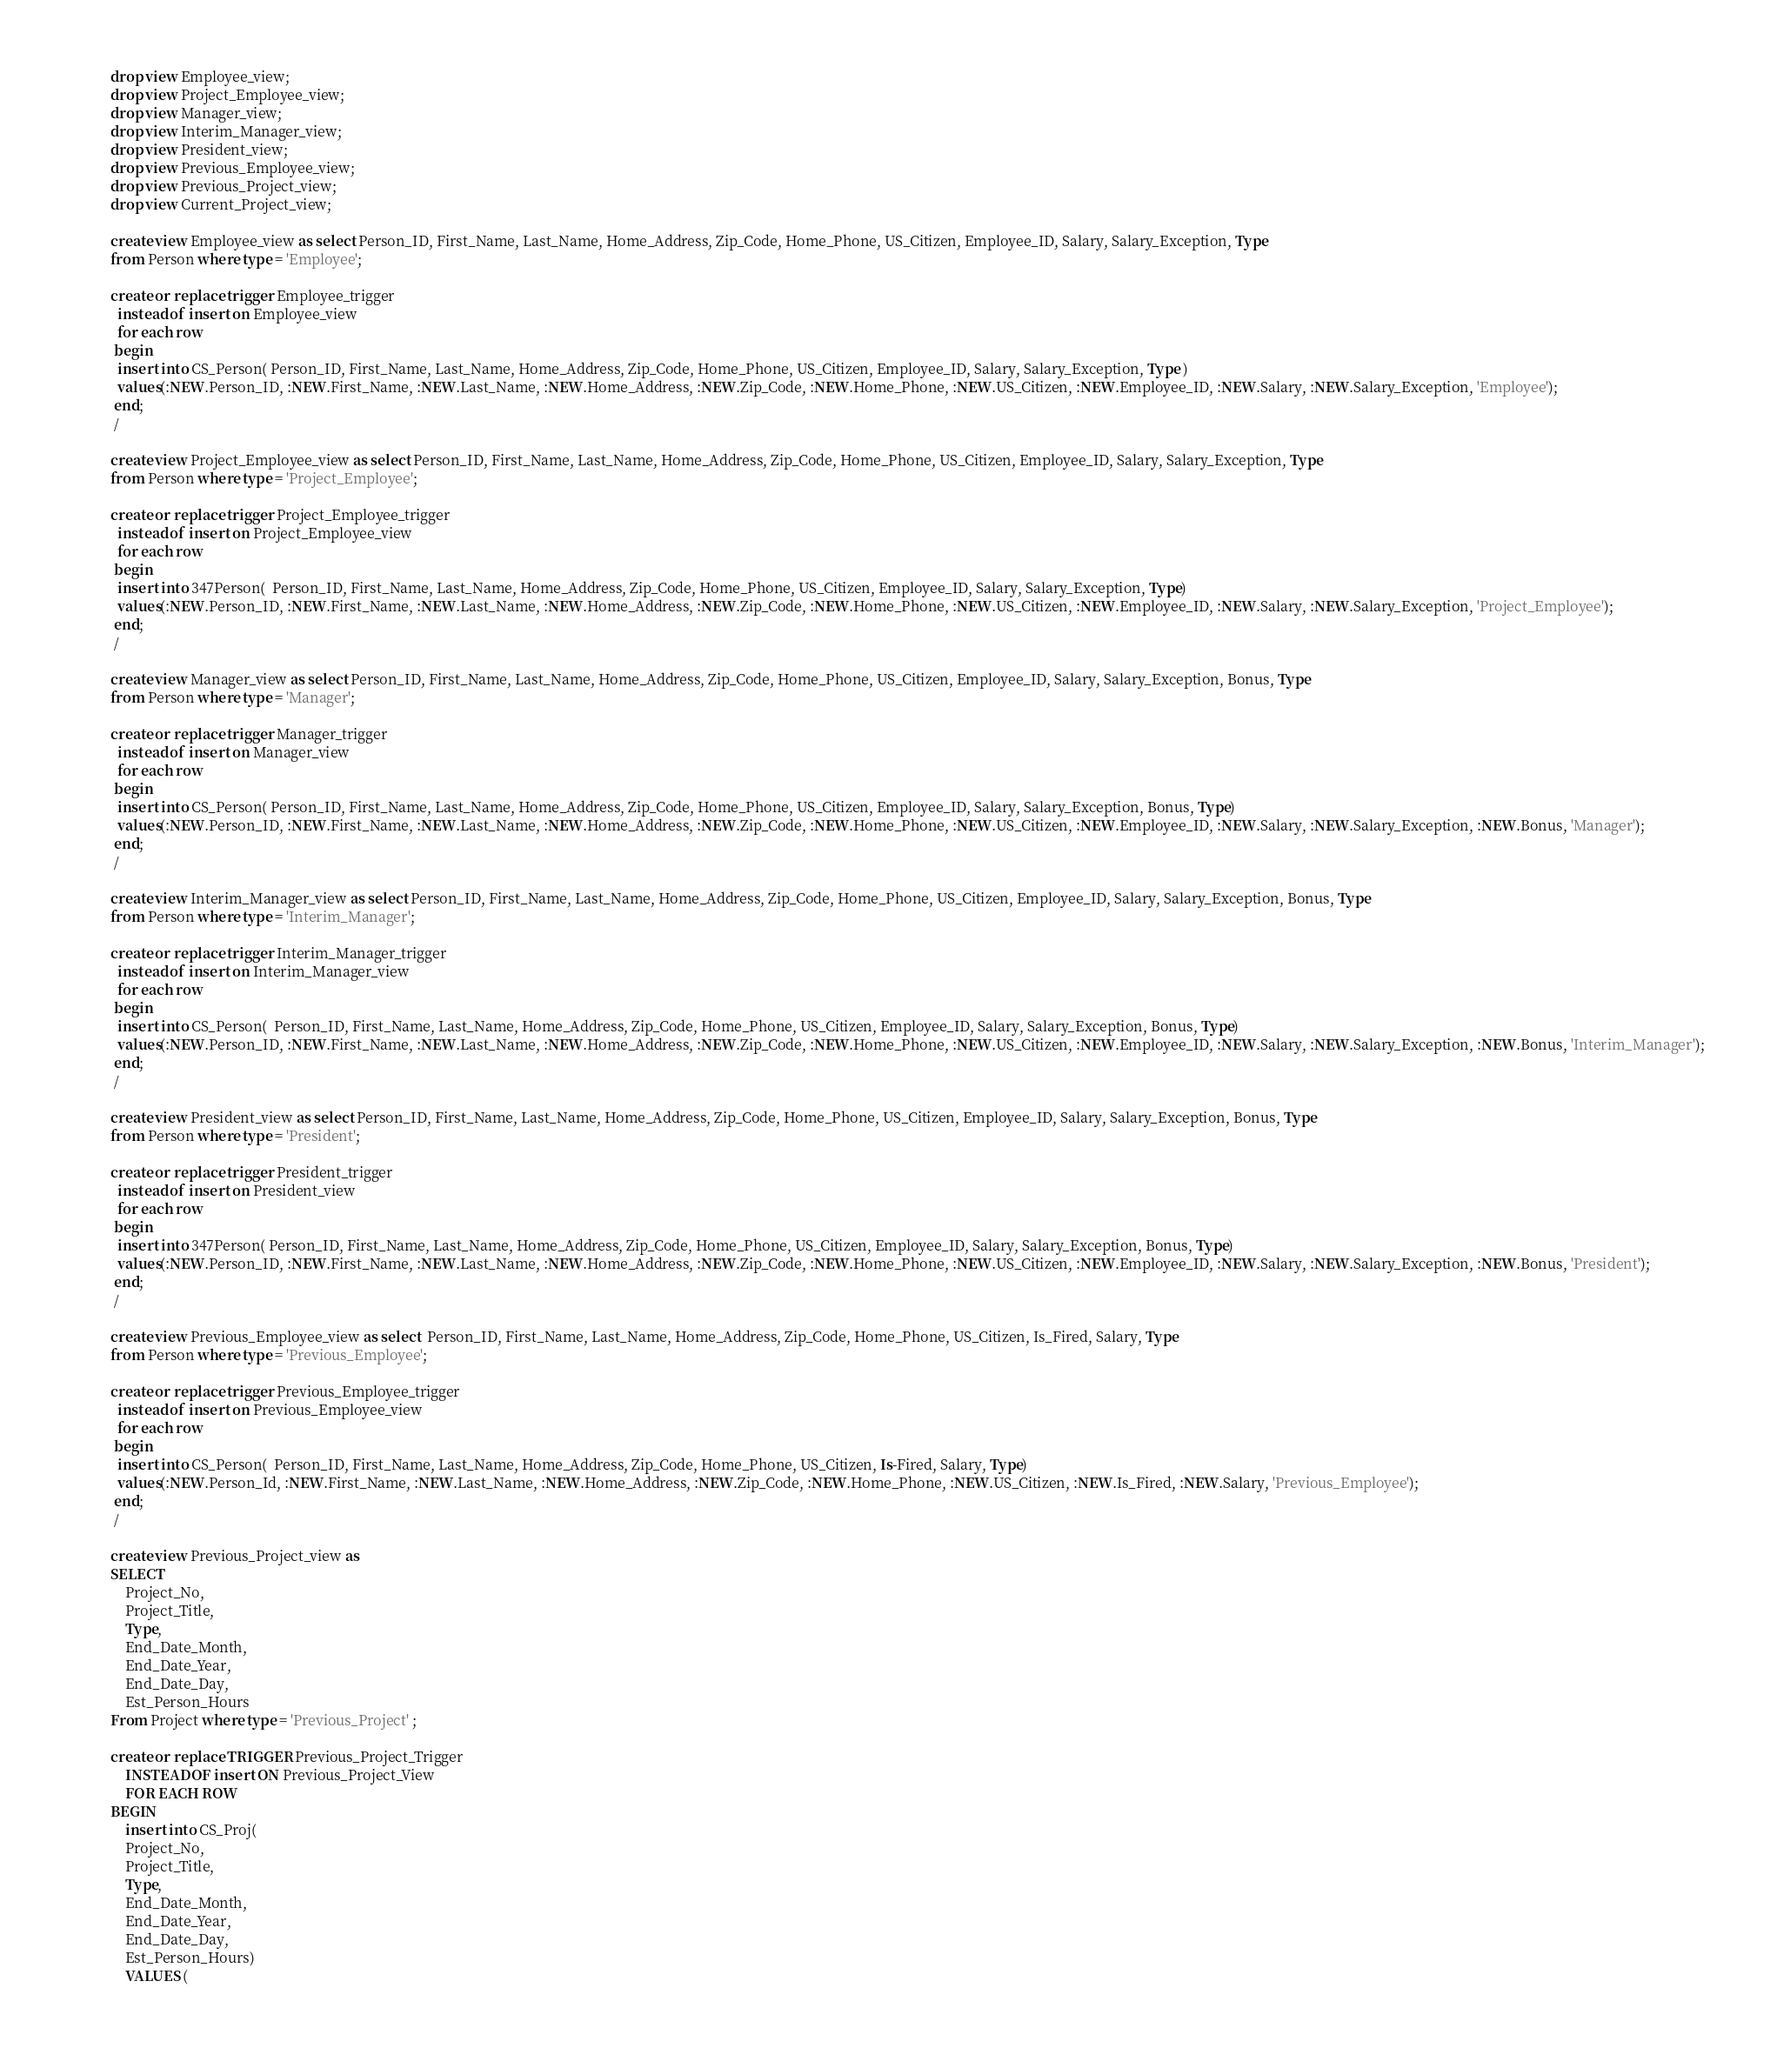<code> <loc_0><loc_0><loc_500><loc_500><_SQL_>drop view Employee_view;
drop view Project_Employee_view;
drop view Manager_view;
drop view Interim_Manager_view;
drop view President_view;
drop view Previous_Employee_view;
drop view Previous_Project_view;
drop view Current_Project_view;

create view Employee_view as select Person_ID, First_Name, Last_Name, Home_Address, Zip_Code, Home_Phone, US_Citizen, Employee_ID, Salary, Salary_Exception, Type 
from Person where type = 'Employee';

create or replace trigger Employee_trigger
  instead of insert on Employee_view
  for each row
 begin
  insert into CS_Person( Person_ID, First_Name, Last_Name, Home_Address, Zip_Code, Home_Phone, US_Citizen, Employee_ID, Salary, Salary_Exception, Type )
  values(:NEW.Person_ID, :NEW.First_Name, :NEW.Last_Name, :NEW.Home_Address, :NEW.Zip_Code, :NEW.Home_Phone, :NEW.US_Citizen, :NEW.Employee_ID, :NEW.Salary, :NEW.Salary_Exception, 'Employee');
 end;
 /

create view Project_Employee_view as select Person_ID, First_Name, Last_Name, Home_Address, Zip_Code, Home_Phone, US_Citizen, Employee_ID, Salary, Salary_Exception, Type
from Person where type = 'Project_Employee';

create or replace trigger Project_Employee_trigger
  instead of insert on Project_Employee_view
  for each row
 begin
  insert into 347Person(  Person_ID, First_Name, Last_Name, Home_Address, Zip_Code, Home_Phone, US_Citizen, Employee_ID, Salary, Salary_Exception, Type)
  values(:NEW.Person_ID, :NEW.First_Name, :NEW.Last_Name, :NEW.Home_Address, :NEW.Zip_Code, :NEW.Home_Phone, :NEW.US_Citizen, :NEW.Employee_ID, :NEW.Salary, :NEW.Salary_Exception, 'Project_Employee');
 end;
 /

create view Manager_view as select Person_ID, First_Name, Last_Name, Home_Address, Zip_Code, Home_Phone, US_Citizen, Employee_ID, Salary, Salary_Exception, Bonus, Type
from Person where type = 'Manager';

create or replace trigger Manager_trigger
  instead of insert on Manager_view
  for each row
 begin
  insert into CS_Person( Person_ID, First_Name, Last_Name, Home_Address, Zip_Code, Home_Phone, US_Citizen, Employee_ID, Salary, Salary_Exception, Bonus, Type)
  values(:NEW.Person_ID, :NEW.First_Name, :NEW.Last_Name, :NEW.Home_Address, :NEW.Zip_Code, :NEW.Home_Phone, :NEW.US_Citizen, :NEW.Employee_ID, :NEW.Salary, :NEW.Salary_Exception, :NEW.Bonus, 'Manager');
 end;
 /

create view Interim_Manager_view as select Person_ID, First_Name, Last_Name, Home_Address, Zip_Code, Home_Phone, US_Citizen, Employee_ID, Salary, Salary_Exception, Bonus, Type
from Person where type = 'Interim_Manager';

create or replace trigger Interim_Manager_trigger
  instead of insert on Interim_Manager_view
  for each row
 begin
  insert into CS_Person(  Person_ID, First_Name, Last_Name, Home_Address, Zip_Code, Home_Phone, US_Citizen, Employee_ID, Salary, Salary_Exception, Bonus, Type)
  values(:NEW.Person_ID, :NEW.First_Name, :NEW.Last_Name, :NEW.Home_Address, :NEW.Zip_Code, :NEW.Home_Phone, :NEW.US_Citizen, :NEW.Employee_ID, :NEW.Salary, :NEW.Salary_Exception, :NEW.Bonus, 'Interim_Manager');
 end;
 /

create view President_view as select Person_ID, First_Name, Last_Name, Home_Address, Zip_Code, Home_Phone, US_Citizen, Employee_ID, Salary, Salary_Exception, Bonus, Type 
from Person where type = 'President';

create or replace trigger President_trigger
  instead of insert on President_view
  for each row
 begin
  insert into 347Person( Person_ID, First_Name, Last_Name, Home_Address, Zip_Code, Home_Phone, US_Citizen, Employee_ID, Salary, Salary_Exception, Bonus, Type)
  values(:NEW.Person_ID, :NEW.First_Name, :NEW.Last_Name, :NEW.Home_Address, :NEW.Zip_Code, :NEW.Home_Phone, :NEW.US_Citizen, :NEW.Employee_ID, :NEW.Salary, :NEW.Salary_Exception, :NEW.Bonus, 'President');
 end;
 /

create view Previous_Employee_view as select  Person_ID, First_Name, Last_Name, Home_Address, Zip_Code, Home_Phone, US_Citizen, Is_Fired, Salary, Type 
from Person where type = 'Previous_Employee';

create or replace trigger Previous_Employee_trigger
  instead of insert on Previous_Employee_view
  for each row
 begin
  insert into CS_Person(  Person_ID, First_Name, Last_Name, Home_Address, Zip_Code, Home_Phone, US_Citizen, Is-Fired, Salary, Type)
  values(:NEW.Person_Id, :NEW.First_Name, :NEW.Last_Name, :NEW.Home_Address, :NEW.Zip_Code, :NEW.Home_Phone, :NEW.US_Citizen, :NEW.Is_Fired, :NEW.Salary, 'Previous_Employee');
 end;
 /

create view Previous_Project_view as 
SELECT
	Project_No,
	Project_Title,
	Type,
	End_Date_Month,
	End_Date_Year,
	End_Date_Day,
	Est_Person_Hours
From Project where type = 'Previous_Project' ;

create or replace TRIGGER Previous_Project_Trigger
	INSTEAD OF insert ON Previous_Project_View
	FOR EACH ROW
BEGIN
	insert into CS_Proj(
	Project_No,
	Project_Title,
	Type,
	End_Date_Month,
	End_Date_Year,
	End_Date_Day,
	Est_Person_Hours)
	VALUES (</code> 